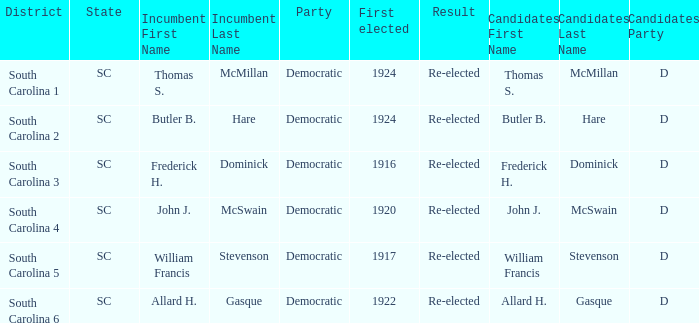What year was william francis stevenson first elected? 1917.0. 